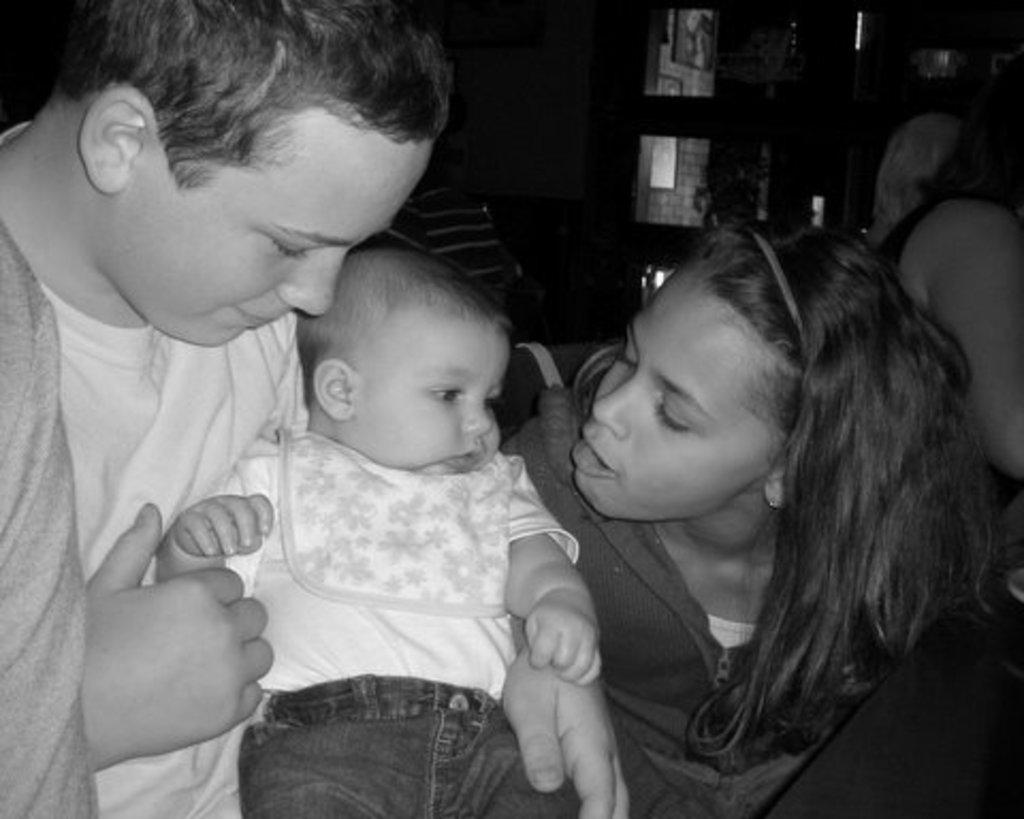What is the boy doing in the image? The boy is holding a baby in the image. Can you describe the girl in the image? There is a girl in the image. What is the girl doing in the image? The girl is talking to the baby. What type of order is the boy giving to the snake in the image? There is no snake present in the image, and therefore no such interaction can be observed. What is the girl using to cut the scissors in the image? There are no scissors present in the image, and therefore no such activity can be observed. 